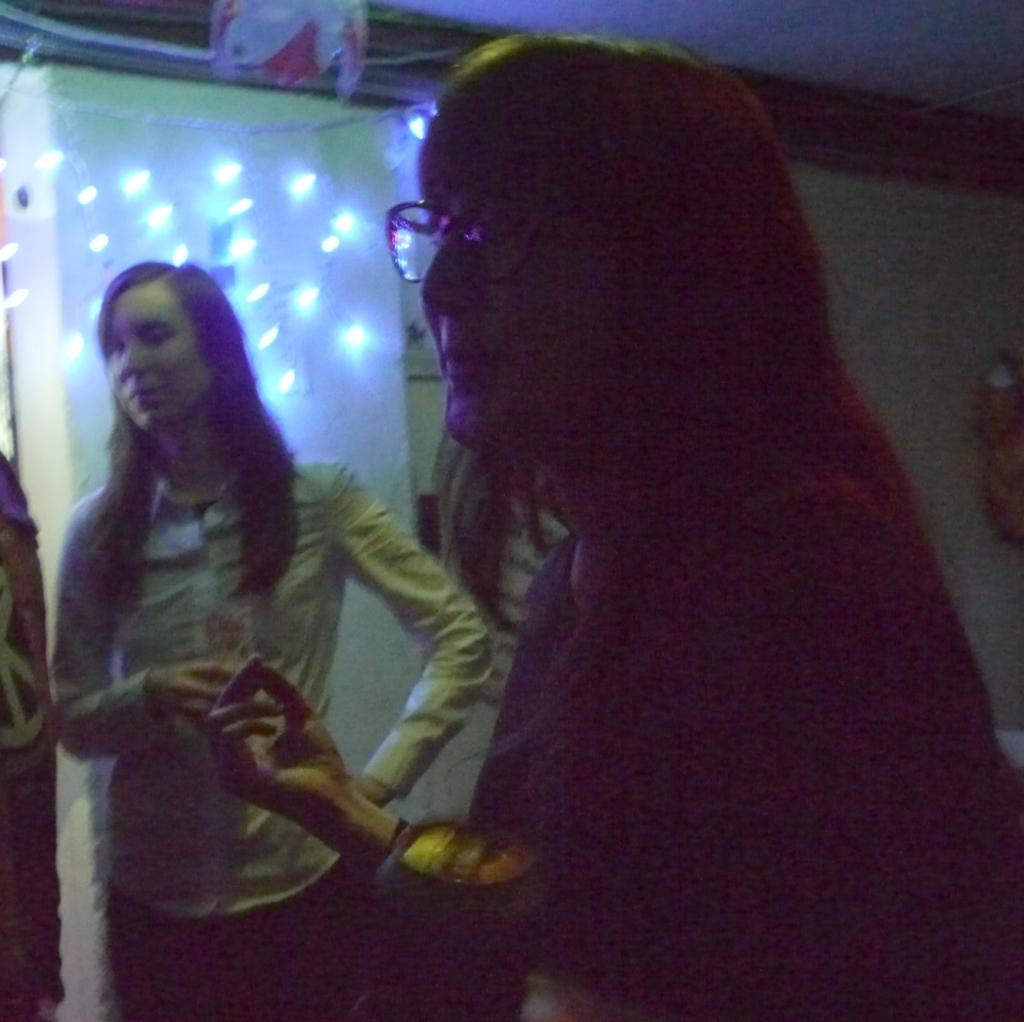At what time of day was the image taken? The image was taken during night time. How many people are present in the image? There are two women in the image. What can be seen in the background of the image? There is a pillar and lights visible in the background of the image. What part of the room is visible in the image? A part of the ceiling is visible in the image. Where is the faucet located in the image? There is no faucet present in the image. What type of fruit is the woman holding in the image? There is no fruit visible in the image, and the women are not holding any objects. 